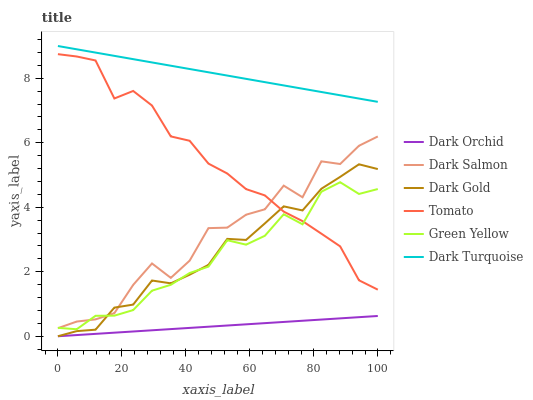Does Dark Orchid have the minimum area under the curve?
Answer yes or no. Yes. Does Dark Turquoise have the maximum area under the curve?
Answer yes or no. Yes. Does Dark Gold have the minimum area under the curve?
Answer yes or no. No. Does Dark Gold have the maximum area under the curve?
Answer yes or no. No. Is Dark Orchid the smoothest?
Answer yes or no. Yes. Is Dark Salmon the roughest?
Answer yes or no. Yes. Is Dark Gold the smoothest?
Answer yes or no. No. Is Dark Gold the roughest?
Answer yes or no. No. Does Dark Turquoise have the lowest value?
Answer yes or no. No. Does Dark Turquoise have the highest value?
Answer yes or no. Yes. Does Dark Gold have the highest value?
Answer yes or no. No. Is Dark Gold less than Dark Turquoise?
Answer yes or no. Yes. Is Dark Turquoise greater than Tomato?
Answer yes or no. Yes. Does Dark Gold intersect Dark Turquoise?
Answer yes or no. No. 